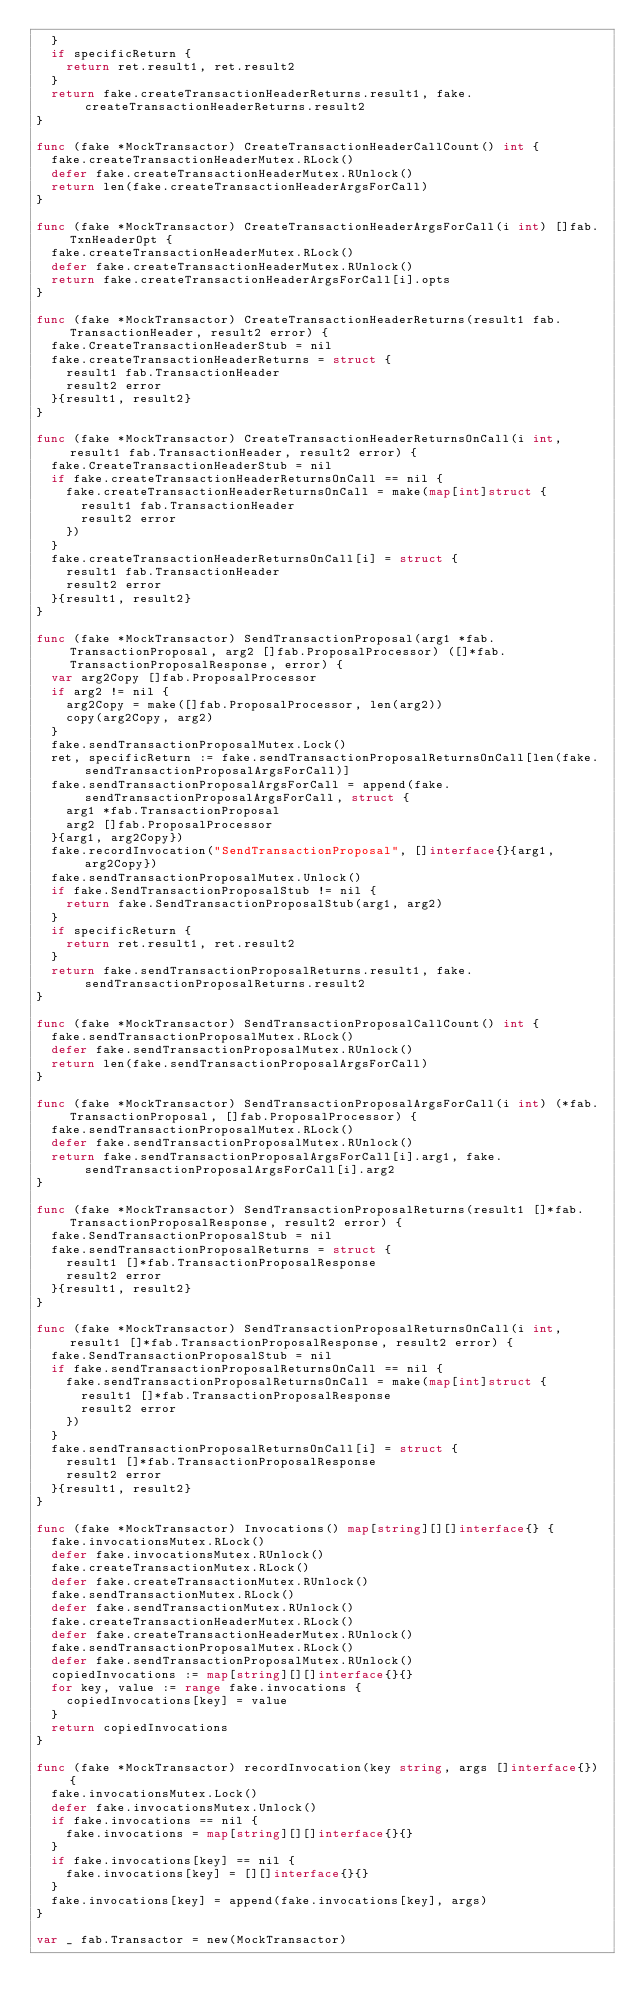<code> <loc_0><loc_0><loc_500><loc_500><_Go_>	}
	if specificReturn {
		return ret.result1, ret.result2
	}
	return fake.createTransactionHeaderReturns.result1, fake.createTransactionHeaderReturns.result2
}

func (fake *MockTransactor) CreateTransactionHeaderCallCount() int {
	fake.createTransactionHeaderMutex.RLock()
	defer fake.createTransactionHeaderMutex.RUnlock()
	return len(fake.createTransactionHeaderArgsForCall)
}

func (fake *MockTransactor) CreateTransactionHeaderArgsForCall(i int) []fab.TxnHeaderOpt {
	fake.createTransactionHeaderMutex.RLock()
	defer fake.createTransactionHeaderMutex.RUnlock()
	return fake.createTransactionHeaderArgsForCall[i].opts
}

func (fake *MockTransactor) CreateTransactionHeaderReturns(result1 fab.TransactionHeader, result2 error) {
	fake.CreateTransactionHeaderStub = nil
	fake.createTransactionHeaderReturns = struct {
		result1 fab.TransactionHeader
		result2 error
	}{result1, result2}
}

func (fake *MockTransactor) CreateTransactionHeaderReturnsOnCall(i int, result1 fab.TransactionHeader, result2 error) {
	fake.CreateTransactionHeaderStub = nil
	if fake.createTransactionHeaderReturnsOnCall == nil {
		fake.createTransactionHeaderReturnsOnCall = make(map[int]struct {
			result1 fab.TransactionHeader
			result2 error
		})
	}
	fake.createTransactionHeaderReturnsOnCall[i] = struct {
		result1 fab.TransactionHeader
		result2 error
	}{result1, result2}
}

func (fake *MockTransactor) SendTransactionProposal(arg1 *fab.TransactionProposal, arg2 []fab.ProposalProcessor) ([]*fab.TransactionProposalResponse, error) {
	var arg2Copy []fab.ProposalProcessor
	if arg2 != nil {
		arg2Copy = make([]fab.ProposalProcessor, len(arg2))
		copy(arg2Copy, arg2)
	}
	fake.sendTransactionProposalMutex.Lock()
	ret, specificReturn := fake.sendTransactionProposalReturnsOnCall[len(fake.sendTransactionProposalArgsForCall)]
	fake.sendTransactionProposalArgsForCall = append(fake.sendTransactionProposalArgsForCall, struct {
		arg1 *fab.TransactionProposal
		arg2 []fab.ProposalProcessor
	}{arg1, arg2Copy})
	fake.recordInvocation("SendTransactionProposal", []interface{}{arg1, arg2Copy})
	fake.sendTransactionProposalMutex.Unlock()
	if fake.SendTransactionProposalStub != nil {
		return fake.SendTransactionProposalStub(arg1, arg2)
	}
	if specificReturn {
		return ret.result1, ret.result2
	}
	return fake.sendTransactionProposalReturns.result1, fake.sendTransactionProposalReturns.result2
}

func (fake *MockTransactor) SendTransactionProposalCallCount() int {
	fake.sendTransactionProposalMutex.RLock()
	defer fake.sendTransactionProposalMutex.RUnlock()
	return len(fake.sendTransactionProposalArgsForCall)
}

func (fake *MockTransactor) SendTransactionProposalArgsForCall(i int) (*fab.TransactionProposal, []fab.ProposalProcessor) {
	fake.sendTransactionProposalMutex.RLock()
	defer fake.sendTransactionProposalMutex.RUnlock()
	return fake.sendTransactionProposalArgsForCall[i].arg1, fake.sendTransactionProposalArgsForCall[i].arg2
}

func (fake *MockTransactor) SendTransactionProposalReturns(result1 []*fab.TransactionProposalResponse, result2 error) {
	fake.SendTransactionProposalStub = nil
	fake.sendTransactionProposalReturns = struct {
		result1 []*fab.TransactionProposalResponse
		result2 error
	}{result1, result2}
}

func (fake *MockTransactor) SendTransactionProposalReturnsOnCall(i int, result1 []*fab.TransactionProposalResponse, result2 error) {
	fake.SendTransactionProposalStub = nil
	if fake.sendTransactionProposalReturnsOnCall == nil {
		fake.sendTransactionProposalReturnsOnCall = make(map[int]struct {
			result1 []*fab.TransactionProposalResponse
			result2 error
		})
	}
	fake.sendTransactionProposalReturnsOnCall[i] = struct {
		result1 []*fab.TransactionProposalResponse
		result2 error
	}{result1, result2}
}

func (fake *MockTransactor) Invocations() map[string][][]interface{} {
	fake.invocationsMutex.RLock()
	defer fake.invocationsMutex.RUnlock()
	fake.createTransactionMutex.RLock()
	defer fake.createTransactionMutex.RUnlock()
	fake.sendTransactionMutex.RLock()
	defer fake.sendTransactionMutex.RUnlock()
	fake.createTransactionHeaderMutex.RLock()
	defer fake.createTransactionHeaderMutex.RUnlock()
	fake.sendTransactionProposalMutex.RLock()
	defer fake.sendTransactionProposalMutex.RUnlock()
	copiedInvocations := map[string][][]interface{}{}
	for key, value := range fake.invocations {
		copiedInvocations[key] = value
	}
	return copiedInvocations
}

func (fake *MockTransactor) recordInvocation(key string, args []interface{}) {
	fake.invocationsMutex.Lock()
	defer fake.invocationsMutex.Unlock()
	if fake.invocations == nil {
		fake.invocations = map[string][][]interface{}{}
	}
	if fake.invocations[key] == nil {
		fake.invocations[key] = [][]interface{}{}
	}
	fake.invocations[key] = append(fake.invocations[key], args)
}

var _ fab.Transactor = new(MockTransactor)
</code> 